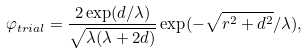Convert formula to latex. <formula><loc_0><loc_0><loc_500><loc_500>\varphi _ { t r i a l } = \frac { 2 \exp ( d / \lambda ) } { \sqrt { \lambda ( \lambda + 2 d ) } } \exp ( - \sqrt { r ^ { 2 } + d ^ { 2 } } / \lambda ) ,</formula> 